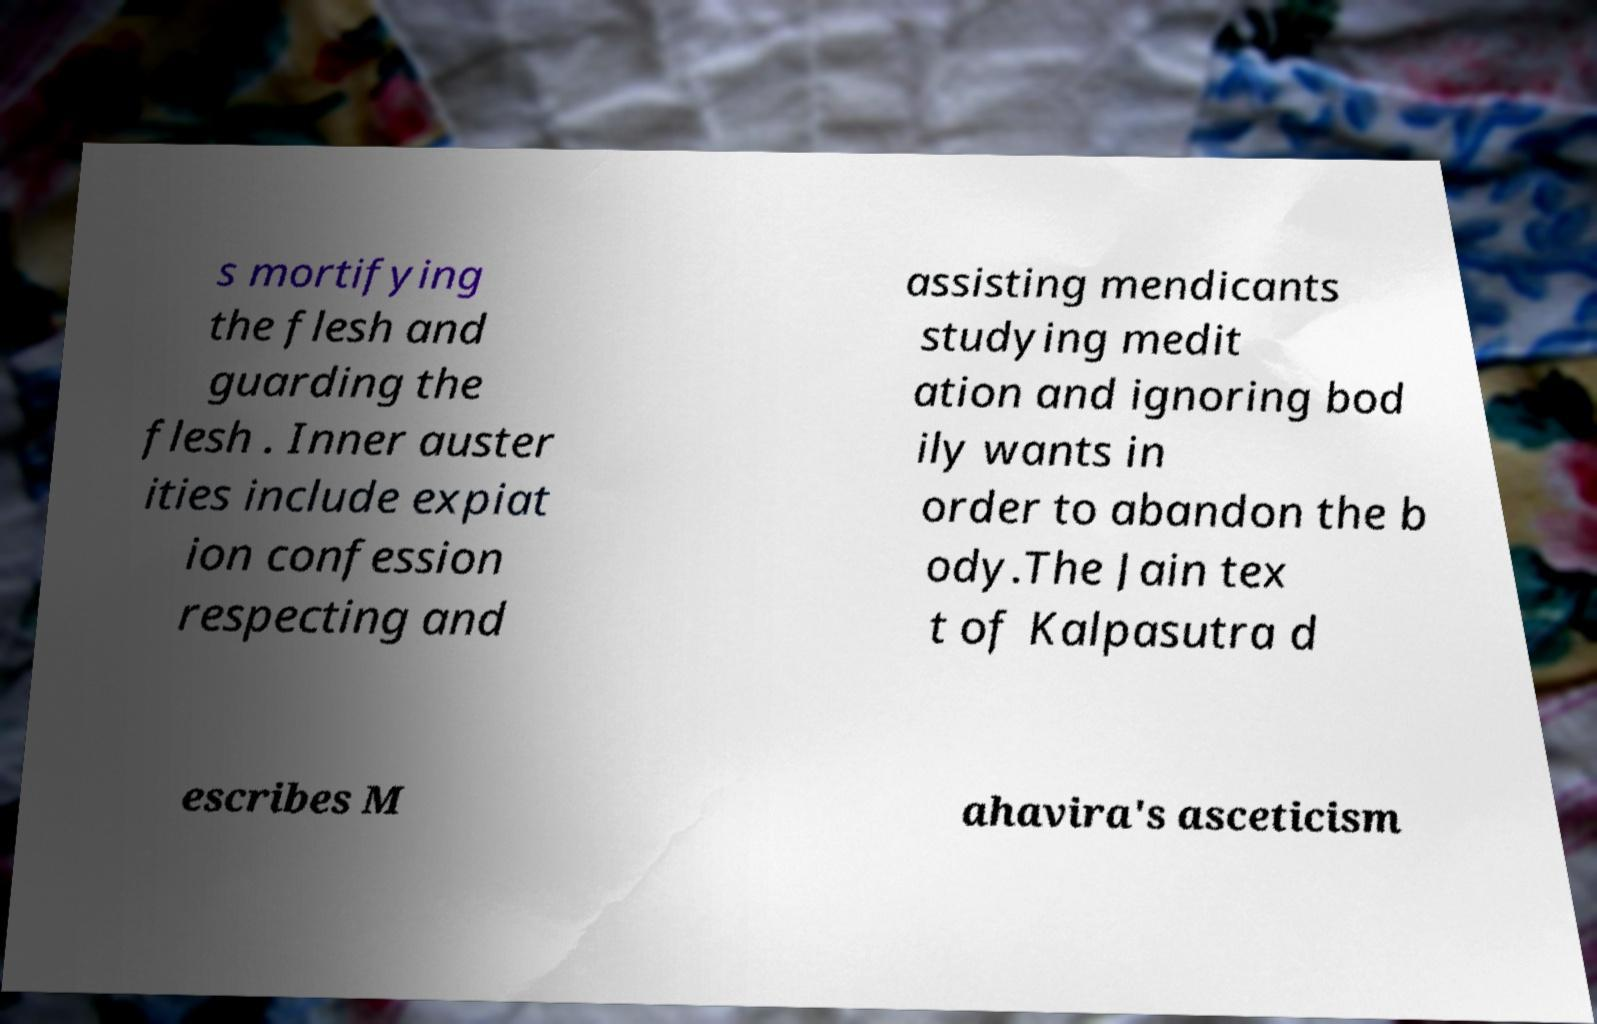For documentation purposes, I need the text within this image transcribed. Could you provide that? s mortifying the flesh and guarding the flesh . Inner auster ities include expiat ion confession respecting and assisting mendicants studying medit ation and ignoring bod ily wants in order to abandon the b ody.The Jain tex t of Kalpasutra d escribes M ahavira's asceticism 